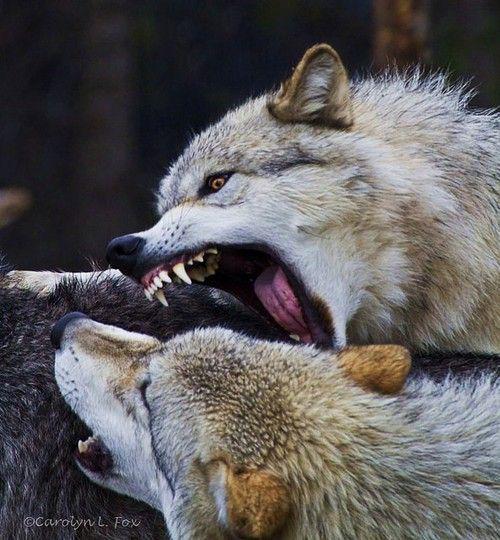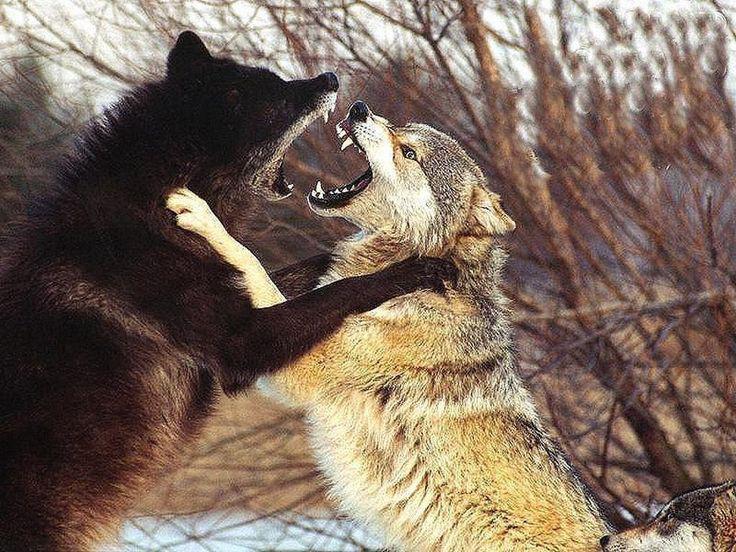The first image is the image on the left, the second image is the image on the right. Evaluate the accuracy of this statement regarding the images: "All of the wolves are on the snow.". Is it true? Answer yes or no. No. 